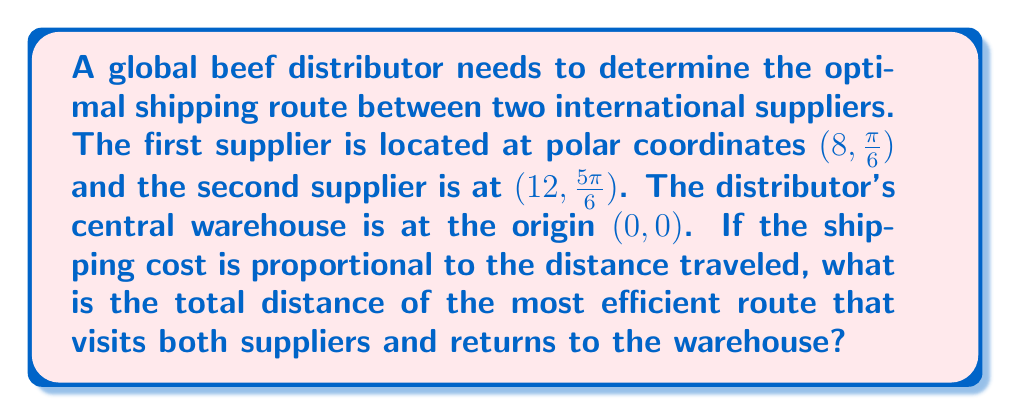Teach me how to tackle this problem. To solve this problem, we need to follow these steps:

1) First, let's visualize the problem using polar coordinates:

[asy]
import geometry;

unitsize(0.5cm);

draw(circle((0,0),8), gray);
draw(circle((0,0),12), gray);

dot((0,0), red);
dot((8*cos(pi/6), 8*sin(pi/6)), blue);
dot((12*cos(5*pi/6), 12*sin(5*pi/6)), blue);

draw((0,0)--(8*cos(pi/6), 8*sin(pi/6)), arrow=Arrow());
draw((8*cos(pi/6), 8*sin(pi/6))--(12*cos(5*pi/6), 12*sin(5*pi/6)), arrow=Arrow());
draw((12*cos(5*pi/6), 12*sin(5*pi/6))--(0,0), arrow=Arrow());

label("Warehouse", (0,-1), S);
label("Supplier 1", (8*cos(pi/6), 8*sin(pi/6)), NE);
label("Supplier 2", (12*cos(5*pi/6), 12*sin(5*pi/6)), NW);
[/asy]

2) The most efficient route will be: Warehouse → Supplier 1 → Supplier 2 → Warehouse

3) To calculate the total distance, we need to sum up three distances:
   a) Distance from Warehouse to Supplier 1
   b) Distance from Supplier 1 to Supplier 2
   c) Distance from Supplier 2 back to Warehouse

4) For the distances from/to the Warehouse, we can simply use the $r$ value in the polar coordinates:
   - Warehouse to Supplier 1: 8
   - Supplier 2 to Warehouse: 12

5) For the distance between the two suppliers, we need to use the polar form of the distance formula:

   $$d = \sqrt{r_1^2 + r_2^2 - 2r_1r_2\cos(\theta_2 - \theta_1)}$$

   Where $(r_1, \theta_1)$ and $(r_2, \theta_2)$ are the polar coordinates of the two points.

6) Plugging in our values:
   $$d = \sqrt{8^2 + 12^2 - 2(8)(12)\cos(\frac{5\pi}{6} - \frac{\pi}{6})}$$
   $$= \sqrt{64 + 144 - 192\cos(\frac{2\pi}{3})}$$
   $$= \sqrt{208 + 96} = \sqrt{304} = 4\sqrt{19}$$

7) Now we can sum up all the distances:
   Total distance = 8 + 4√19 + 12 = 20 + 4√19
Answer: The total distance of the most efficient route is $20 + 4\sqrt{19}$ units. 